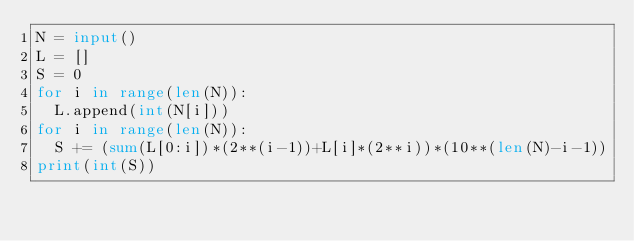<code> <loc_0><loc_0><loc_500><loc_500><_Python_>N = input()
L = []
S = 0
for i in range(len(N)):
  L.append(int(N[i]))
for i in range(len(N)):
  S += (sum(L[0:i])*(2**(i-1))+L[i]*(2**i))*(10**(len(N)-i-1))
print(int(S))</code> 